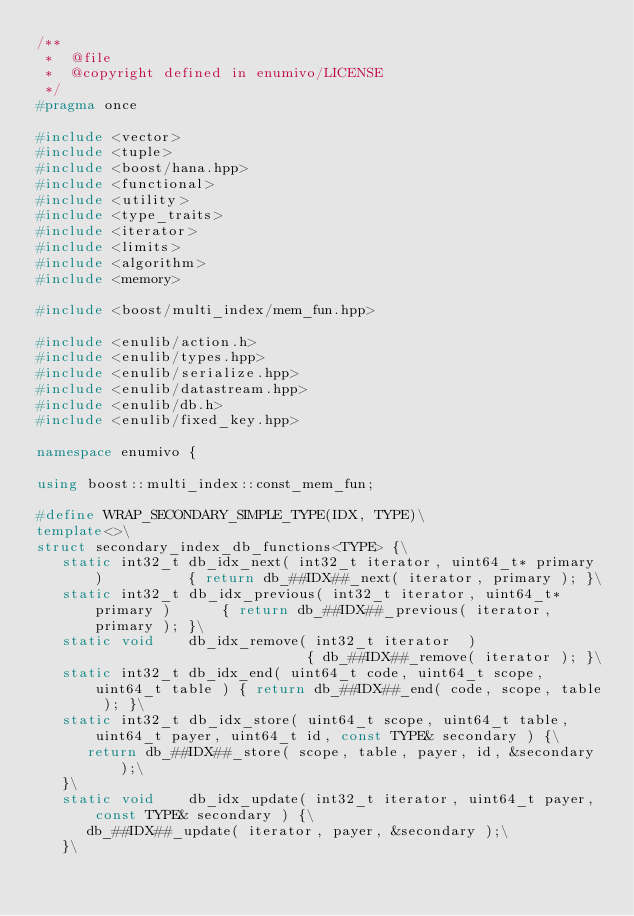Convert code to text. <code><loc_0><loc_0><loc_500><loc_500><_C++_>/**
 *  @file
 *  @copyright defined in enumivo/LICENSE
 */
#pragma once

#include <vector>
#include <tuple>
#include <boost/hana.hpp>
#include <functional>
#include <utility>
#include <type_traits>
#include <iterator>
#include <limits>
#include <algorithm>
#include <memory>

#include <boost/multi_index/mem_fun.hpp>

#include <enulib/action.h>
#include <enulib/types.hpp>
#include <enulib/serialize.hpp>
#include <enulib/datastream.hpp>
#include <enulib/db.h>
#include <enulib/fixed_key.hpp>

namespace enumivo {

using boost::multi_index::const_mem_fun;

#define WRAP_SECONDARY_SIMPLE_TYPE(IDX, TYPE)\
template<>\
struct secondary_index_db_functions<TYPE> {\
   static int32_t db_idx_next( int32_t iterator, uint64_t* primary )          { return db_##IDX##_next( iterator, primary ); }\
   static int32_t db_idx_previous( int32_t iterator, uint64_t* primary )      { return db_##IDX##_previous( iterator, primary ); }\
   static void    db_idx_remove( int32_t iterator  )                          { db_##IDX##_remove( iterator ); }\
   static int32_t db_idx_end( uint64_t code, uint64_t scope, uint64_t table ) { return db_##IDX##_end( code, scope, table ); }\
   static int32_t db_idx_store( uint64_t scope, uint64_t table, uint64_t payer, uint64_t id, const TYPE& secondary ) {\
      return db_##IDX##_store( scope, table, payer, id, &secondary );\
   }\
   static void    db_idx_update( int32_t iterator, uint64_t payer, const TYPE& secondary ) {\
      db_##IDX##_update( iterator, payer, &secondary );\
   }\</code> 